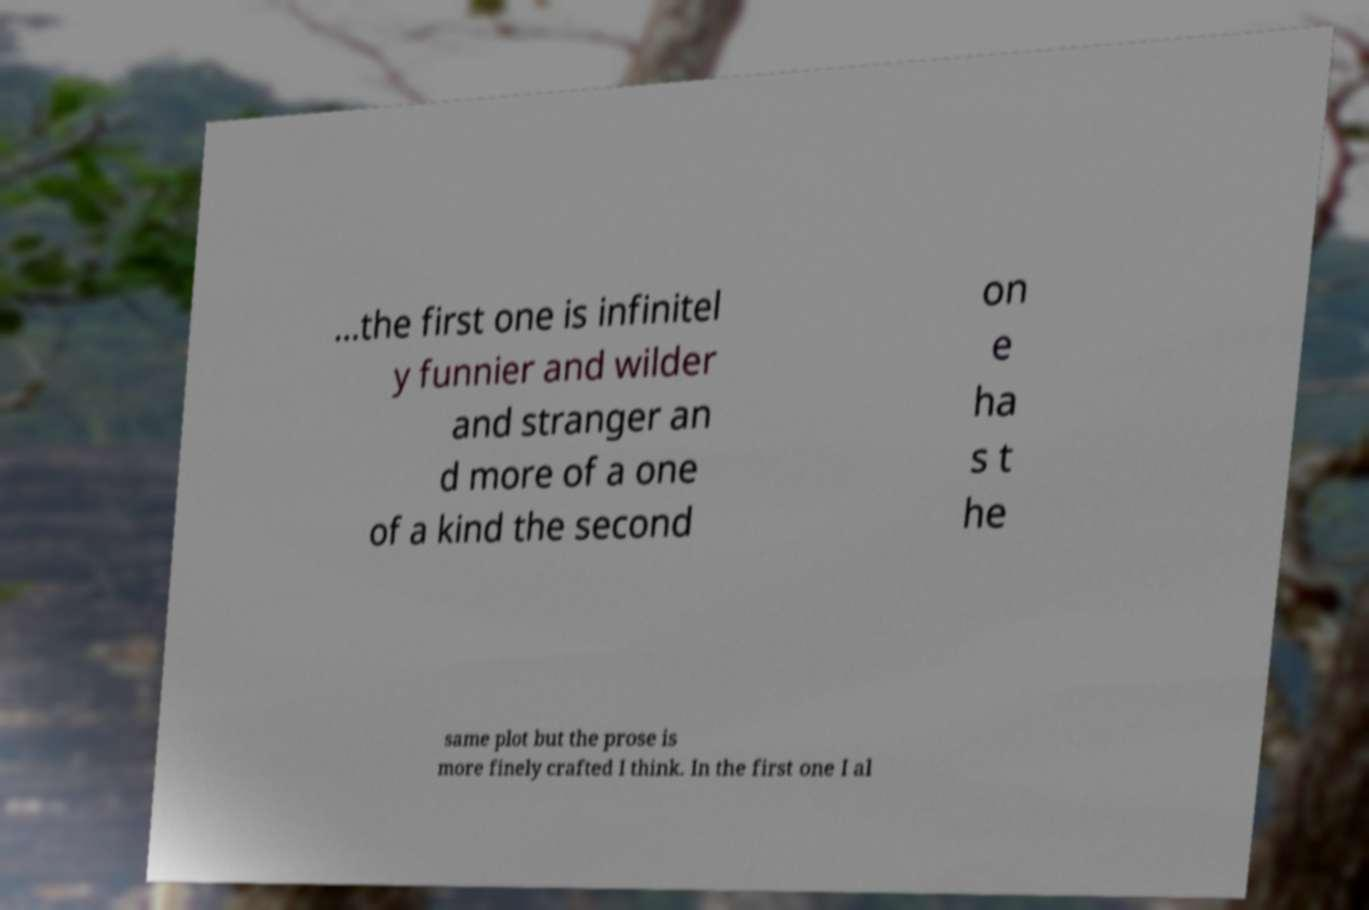Please identify and transcribe the text found in this image. ...the first one is infinitel y funnier and wilder and stranger an d more of a one of a kind the second on e ha s t he same plot but the prose is more finely crafted I think. In the first one I al 